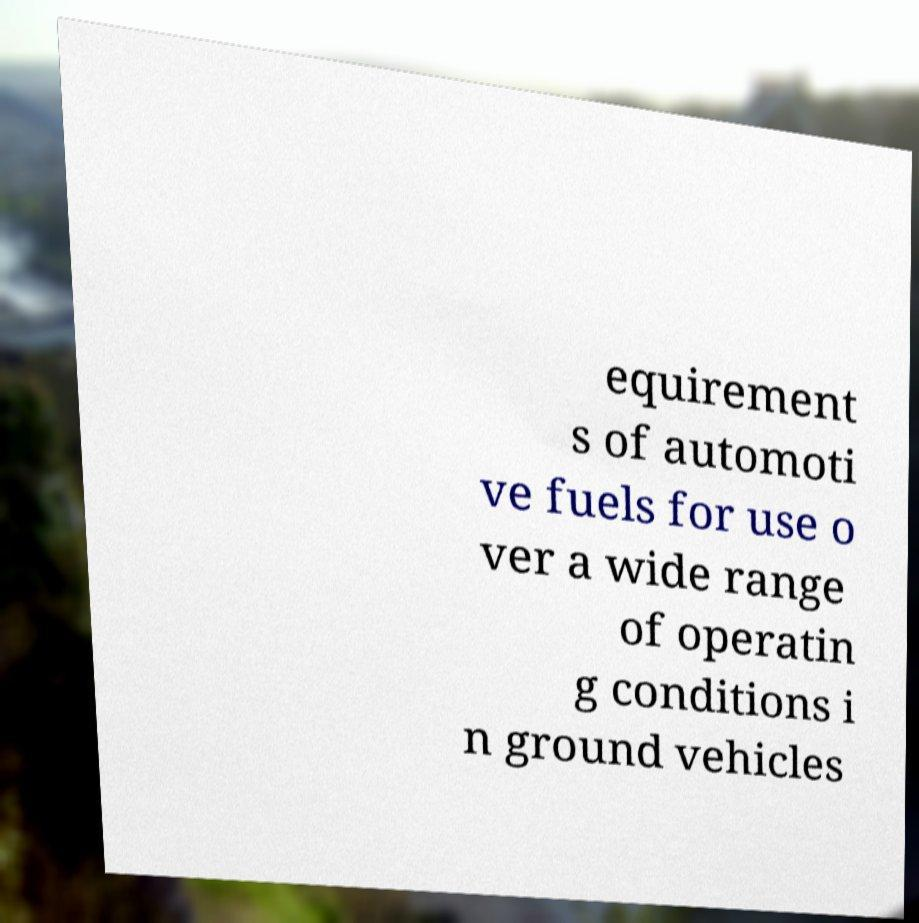Can you accurately transcribe the text from the provided image for me? equirement s of automoti ve fuels for use o ver a wide range of operatin g conditions i n ground vehicles 